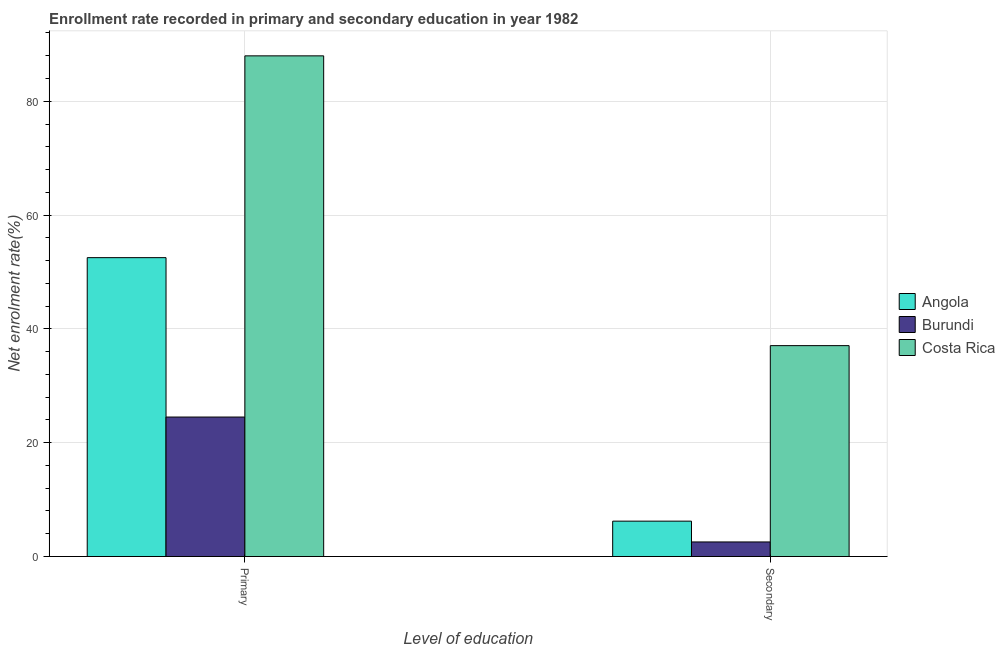How many different coloured bars are there?
Ensure brevity in your answer.  3. Are the number of bars on each tick of the X-axis equal?
Offer a very short reply. Yes. How many bars are there on the 2nd tick from the right?
Ensure brevity in your answer.  3. What is the label of the 2nd group of bars from the left?
Give a very brief answer. Secondary. What is the enrollment rate in primary education in Costa Rica?
Offer a terse response. 87.98. Across all countries, what is the maximum enrollment rate in primary education?
Keep it short and to the point. 87.98. Across all countries, what is the minimum enrollment rate in primary education?
Provide a short and direct response. 24.51. In which country was the enrollment rate in primary education minimum?
Your response must be concise. Burundi. What is the total enrollment rate in secondary education in the graph?
Your answer should be very brief. 45.83. What is the difference between the enrollment rate in secondary education in Costa Rica and that in Burundi?
Your answer should be very brief. 34.5. What is the difference between the enrollment rate in secondary education in Angola and the enrollment rate in primary education in Burundi?
Provide a succinct answer. -18.3. What is the average enrollment rate in secondary education per country?
Ensure brevity in your answer.  15.28. What is the difference between the enrollment rate in secondary education and enrollment rate in primary education in Costa Rica?
Offer a very short reply. -50.92. In how many countries, is the enrollment rate in secondary education greater than 36 %?
Offer a terse response. 1. What is the ratio of the enrollment rate in secondary education in Costa Rica to that in Burundi?
Ensure brevity in your answer.  14.47. Is the enrollment rate in primary education in Costa Rica less than that in Burundi?
Your response must be concise. No. What does the 2nd bar from the left in Secondary represents?
Give a very brief answer. Burundi. How many bars are there?
Your answer should be very brief. 6. How many countries are there in the graph?
Your answer should be very brief. 3. What is the difference between two consecutive major ticks on the Y-axis?
Provide a succinct answer. 20. Are the values on the major ticks of Y-axis written in scientific E-notation?
Your answer should be compact. No. Does the graph contain any zero values?
Provide a short and direct response. No. Where does the legend appear in the graph?
Your answer should be compact. Center right. How are the legend labels stacked?
Keep it short and to the point. Vertical. What is the title of the graph?
Give a very brief answer. Enrollment rate recorded in primary and secondary education in year 1982. Does "Liechtenstein" appear as one of the legend labels in the graph?
Your response must be concise. No. What is the label or title of the X-axis?
Ensure brevity in your answer.  Level of education. What is the label or title of the Y-axis?
Offer a terse response. Net enrolment rate(%). What is the Net enrolment rate(%) in Angola in Primary?
Your answer should be very brief. 52.52. What is the Net enrolment rate(%) of Burundi in Primary?
Offer a very short reply. 24.51. What is the Net enrolment rate(%) in Costa Rica in Primary?
Give a very brief answer. 87.98. What is the Net enrolment rate(%) of Angola in Secondary?
Make the answer very short. 6.22. What is the Net enrolment rate(%) of Burundi in Secondary?
Your answer should be very brief. 2.56. What is the Net enrolment rate(%) of Costa Rica in Secondary?
Offer a terse response. 37.06. Across all Level of education, what is the maximum Net enrolment rate(%) of Angola?
Keep it short and to the point. 52.52. Across all Level of education, what is the maximum Net enrolment rate(%) in Burundi?
Give a very brief answer. 24.51. Across all Level of education, what is the maximum Net enrolment rate(%) of Costa Rica?
Make the answer very short. 87.98. Across all Level of education, what is the minimum Net enrolment rate(%) in Angola?
Provide a short and direct response. 6.22. Across all Level of education, what is the minimum Net enrolment rate(%) of Burundi?
Your answer should be very brief. 2.56. Across all Level of education, what is the minimum Net enrolment rate(%) of Costa Rica?
Offer a very short reply. 37.06. What is the total Net enrolment rate(%) of Angola in the graph?
Keep it short and to the point. 58.74. What is the total Net enrolment rate(%) of Burundi in the graph?
Keep it short and to the point. 27.07. What is the total Net enrolment rate(%) in Costa Rica in the graph?
Your answer should be very brief. 125.04. What is the difference between the Net enrolment rate(%) of Angola in Primary and that in Secondary?
Provide a short and direct response. 46.31. What is the difference between the Net enrolment rate(%) of Burundi in Primary and that in Secondary?
Ensure brevity in your answer.  21.95. What is the difference between the Net enrolment rate(%) in Costa Rica in Primary and that in Secondary?
Provide a succinct answer. 50.92. What is the difference between the Net enrolment rate(%) of Angola in Primary and the Net enrolment rate(%) of Burundi in Secondary?
Offer a very short reply. 49.96. What is the difference between the Net enrolment rate(%) in Angola in Primary and the Net enrolment rate(%) in Costa Rica in Secondary?
Your answer should be very brief. 15.46. What is the difference between the Net enrolment rate(%) of Burundi in Primary and the Net enrolment rate(%) of Costa Rica in Secondary?
Give a very brief answer. -12.55. What is the average Net enrolment rate(%) of Angola per Level of education?
Offer a very short reply. 29.37. What is the average Net enrolment rate(%) in Burundi per Level of education?
Keep it short and to the point. 13.54. What is the average Net enrolment rate(%) of Costa Rica per Level of education?
Keep it short and to the point. 62.52. What is the difference between the Net enrolment rate(%) of Angola and Net enrolment rate(%) of Burundi in Primary?
Provide a succinct answer. 28.01. What is the difference between the Net enrolment rate(%) in Angola and Net enrolment rate(%) in Costa Rica in Primary?
Your answer should be compact. -35.46. What is the difference between the Net enrolment rate(%) of Burundi and Net enrolment rate(%) of Costa Rica in Primary?
Your response must be concise. -63.47. What is the difference between the Net enrolment rate(%) of Angola and Net enrolment rate(%) of Burundi in Secondary?
Your response must be concise. 3.65. What is the difference between the Net enrolment rate(%) of Angola and Net enrolment rate(%) of Costa Rica in Secondary?
Give a very brief answer. -30.84. What is the difference between the Net enrolment rate(%) in Burundi and Net enrolment rate(%) in Costa Rica in Secondary?
Keep it short and to the point. -34.5. What is the ratio of the Net enrolment rate(%) in Angola in Primary to that in Secondary?
Offer a very short reply. 8.45. What is the ratio of the Net enrolment rate(%) in Burundi in Primary to that in Secondary?
Provide a succinct answer. 9.57. What is the ratio of the Net enrolment rate(%) in Costa Rica in Primary to that in Secondary?
Offer a very short reply. 2.37. What is the difference between the highest and the second highest Net enrolment rate(%) of Angola?
Ensure brevity in your answer.  46.31. What is the difference between the highest and the second highest Net enrolment rate(%) in Burundi?
Your answer should be compact. 21.95. What is the difference between the highest and the second highest Net enrolment rate(%) of Costa Rica?
Your answer should be compact. 50.92. What is the difference between the highest and the lowest Net enrolment rate(%) in Angola?
Provide a short and direct response. 46.31. What is the difference between the highest and the lowest Net enrolment rate(%) in Burundi?
Keep it short and to the point. 21.95. What is the difference between the highest and the lowest Net enrolment rate(%) in Costa Rica?
Your answer should be very brief. 50.92. 